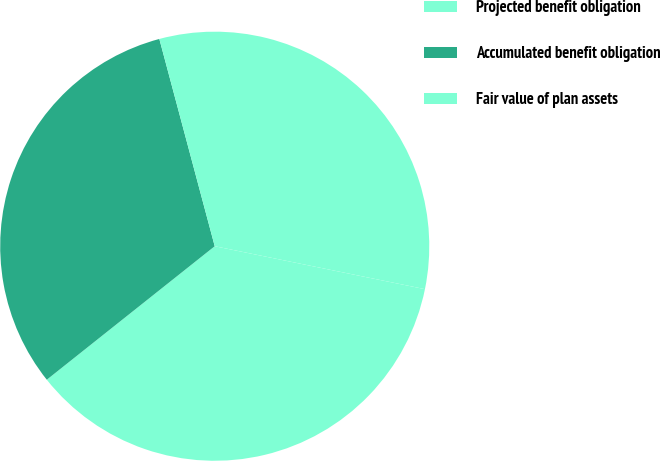Convert chart. <chart><loc_0><loc_0><loc_500><loc_500><pie_chart><fcel>Projected benefit obligation<fcel>Accumulated benefit obligation<fcel>Fair value of plan assets<nl><fcel>36.1%<fcel>31.53%<fcel>32.36%<nl></chart> 